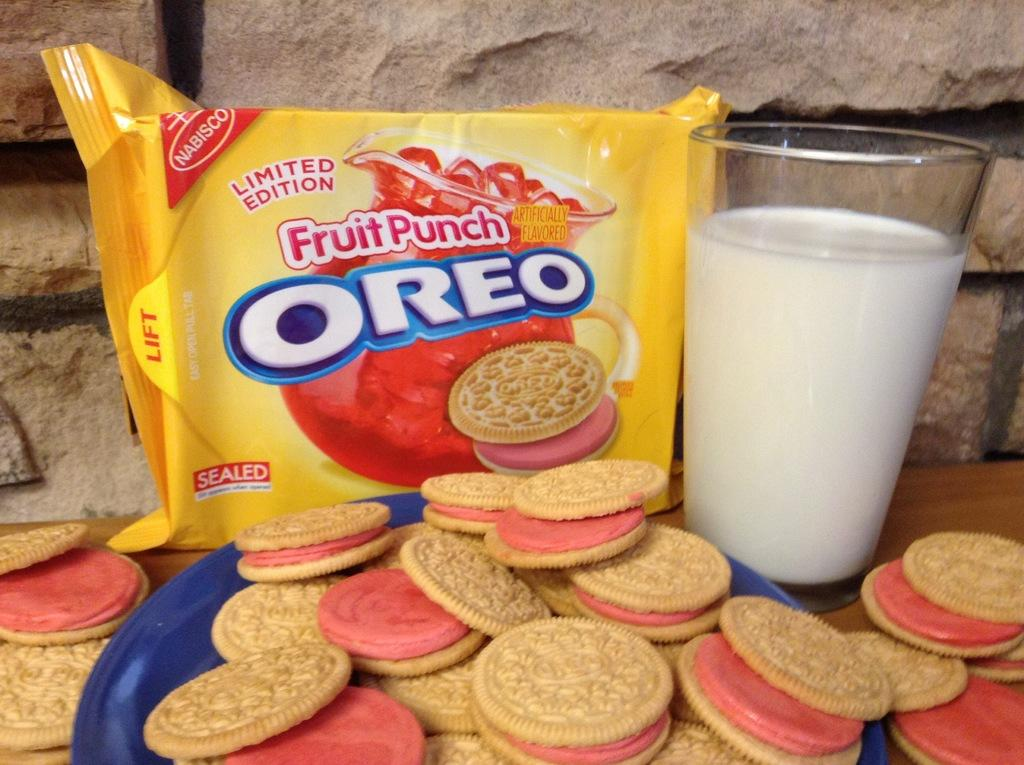What is the main structure in the image? There is a platform in the image. What is placed on the platform? A plate, a packet, biscuits, and a glass with milk are visible on the platform. What is the background of the image? There is a wall in the background of the image. What type of thread is being used by the father in the image? There is no father or thread present in the image. What town is visible in the background of the image? The image does not show a town or any indication of a specific location. 